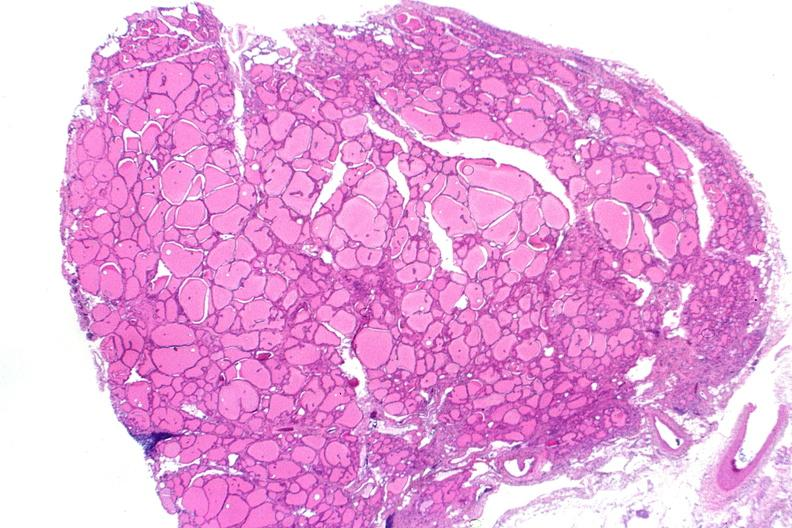does vessel show thyroid, normal?
Answer the question using a single word or phrase. No 